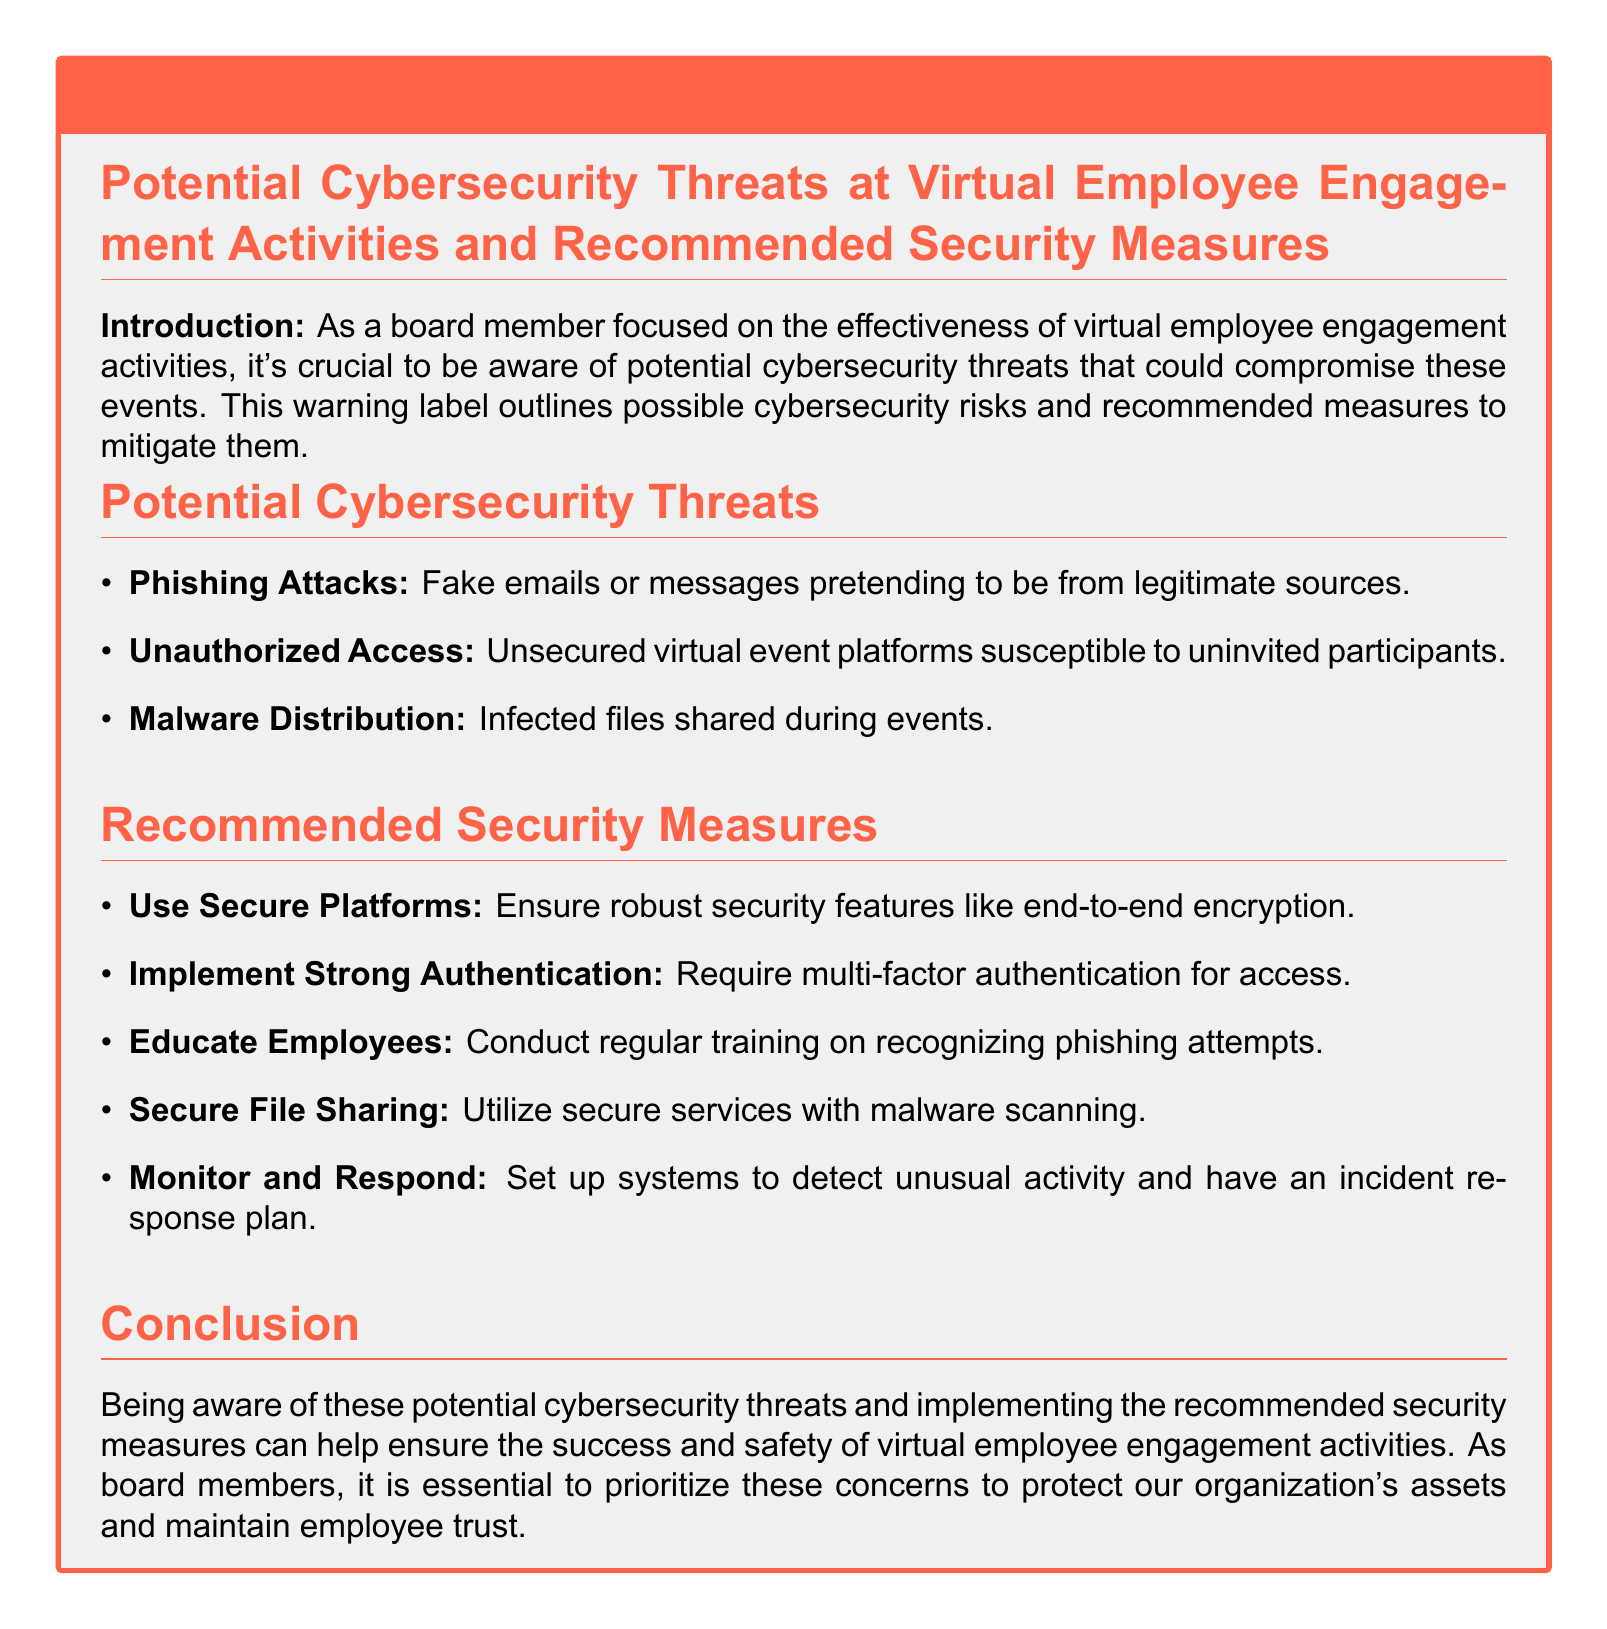What are the potential cybersecurity threats? The document lists phishing attacks, unauthorized access, and malware distribution as potential threats.
Answer: Phishing attacks, unauthorized access, malware distribution What is the color of the warning box title? The title color of the warning box is defined in the document as warning red.
Answer: Warning red What is one recommended security measure? The document provides several recommended measures, one of which is to use secure platforms.
Answer: Use secure platforms How many potential cybersecurity threats are mentioned? The document mentions three potential threats under the section "Potential Cybersecurity Threats."
Answer: Three What is the purpose of the document? According to the introduction, the purpose is to be aware of potential cybersecurity threats that could compromise virtual employee engagement activities.
Answer: Awareness of potential cybersecurity threats 